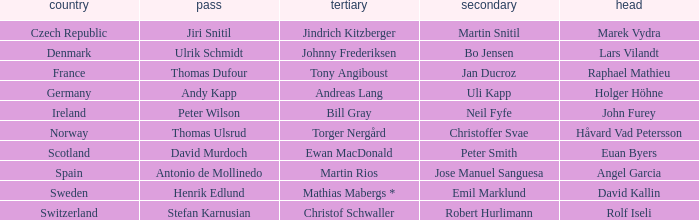When did France come in second? Jan Ducroz. 